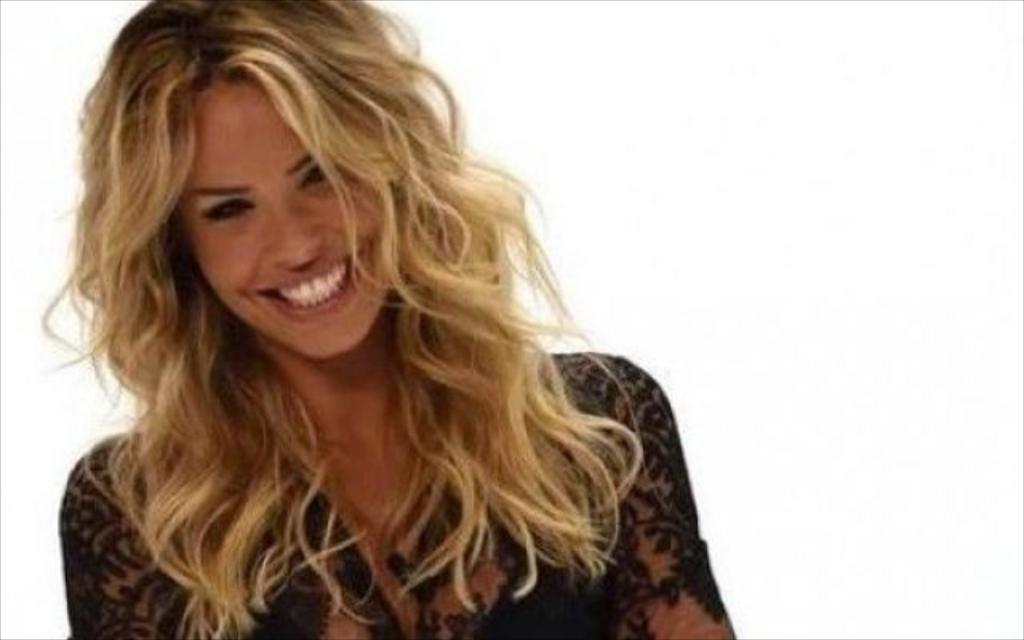Who is the main subject in the image? There is a woman in the image. What is the woman wearing? The woman is wearing a black dress. Can you describe the woman's hair? The woman has cream-colored hair. What expression does the woman have? The woman is smiling. What is the color of the background in the image? There is a white background in the image. What type of shoe can be seen on the woman's foot in the image? There is no shoe visible on the woman's foot in the image. Can you hear a bell ringing in the image? There is no bell present in the image, so it is not possible to hear it ringing. 